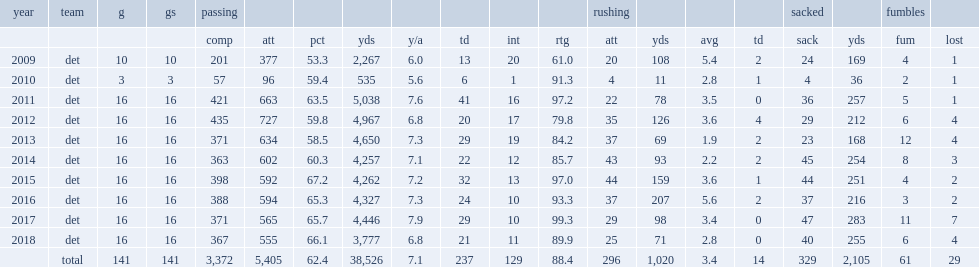How many passing yards did stafford finish the 2013 season with? 4650.0. How many touchdowns did stafford finish the 2013 season with? 29.0. How many interceptions did stafford finish the 2013 season with? 19.0. 